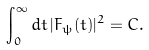<formula> <loc_0><loc_0><loc_500><loc_500>\int _ { 0 } ^ { \infty } d t \, | F _ { \psi } ( t ) | ^ { 2 } = C .</formula> 